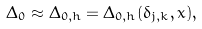<formula> <loc_0><loc_0><loc_500><loc_500>\Delta _ { 0 } \approx \Delta _ { 0 , h } = \Delta _ { 0 , h } ( \delta _ { j , k } , x ) ,</formula> 